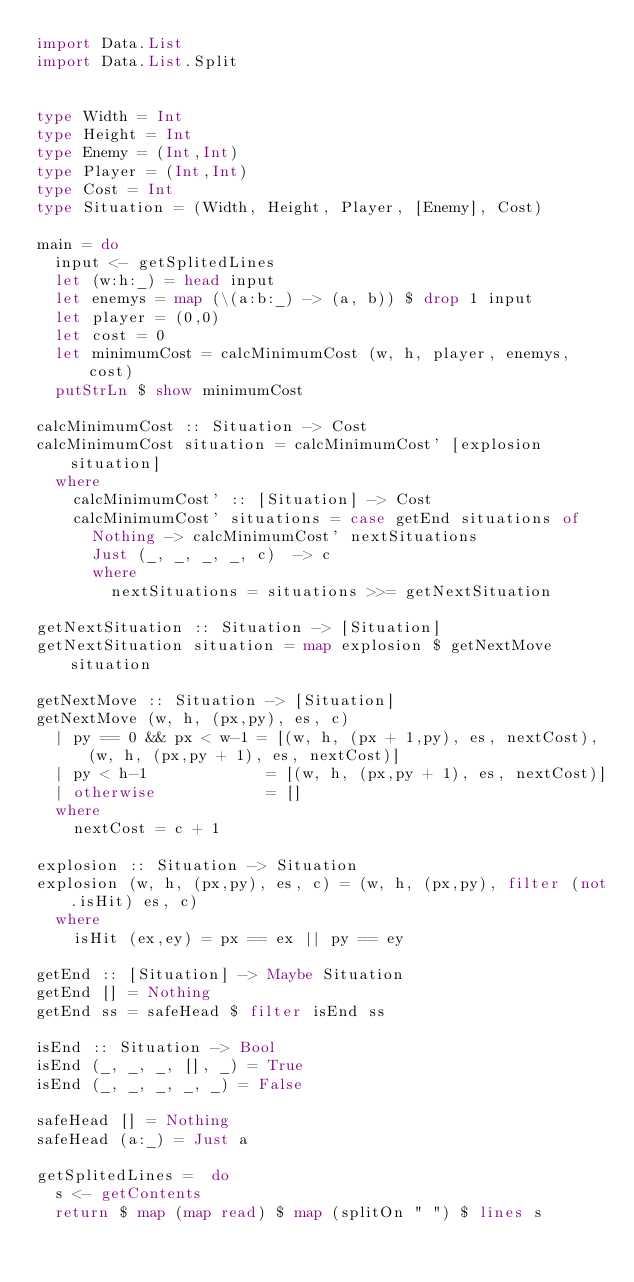<code> <loc_0><loc_0><loc_500><loc_500><_Haskell_>import Data.List
import Data.List.Split


type Width = Int
type Height = Int
type Enemy = (Int,Int)
type Player = (Int,Int)
type Cost = Int
type Situation = (Width, Height, Player, [Enemy], Cost)

main = do
  input <- getSplitedLines
  let (w:h:_) = head input
  let enemys = map (\(a:b:_) -> (a, b)) $ drop 1 input
  let player = (0,0)
  let cost = 0
  let minimumCost = calcMinimumCost (w, h, player, enemys, cost)
  putStrLn $ show minimumCost

calcMinimumCost :: Situation -> Cost
calcMinimumCost situation = calcMinimumCost' [explosion situation]
  where
    calcMinimumCost' :: [Situation] -> Cost
    calcMinimumCost' situations = case getEnd situations of
      Nothing -> calcMinimumCost' nextSituations
      Just (_, _, _, _, c)  -> c
      where
        nextSituations = situations >>= getNextSituation

getNextSituation :: Situation -> [Situation]
getNextSituation situation = map explosion $ getNextMove situation

getNextMove :: Situation -> [Situation]
getNextMove (w, h, (px,py), es, c)
  | py == 0 && px < w-1 = [(w, h, (px + 1,py), es, nextCost), (w, h, (px,py + 1), es, nextCost)]
  | py < h-1             = [(w, h, (px,py + 1), es, nextCost)]
  | otherwise			 = []
  where 
    nextCost = c + 1

explosion :: Situation -> Situation
explosion (w, h, (px,py), es, c) = (w, h, (px,py), filter (not.isHit) es, c)
  where
    isHit (ex,ey) = px == ex || py == ey

getEnd :: [Situation] -> Maybe Situation
getEnd [] = Nothing
getEnd ss = safeHead $ filter isEnd ss

isEnd :: Situation -> Bool
isEnd (_, _, _, [], _) = True
isEnd (_, _, _, _, _) = False
    
safeHead [] = Nothing
safeHead (a:_) = Just a

getSplitedLines =  do
  s <- getContents
  return $ map (map read) $ map (splitOn " ") $ lines s


</code> 